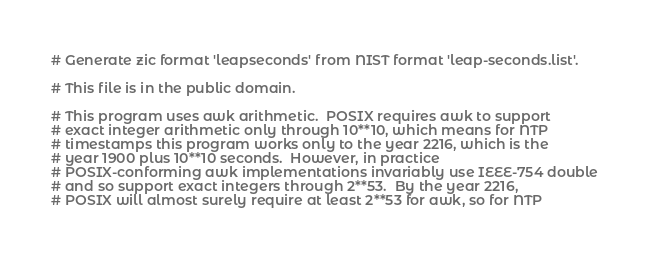Convert code to text. <code><loc_0><loc_0><loc_500><loc_500><_Awk_># Generate zic format 'leapseconds' from NIST format 'leap-seconds.list'.

# This file is in the public domain.

# This program uses awk arithmetic.  POSIX requires awk to support
# exact integer arithmetic only through 10**10, which means for NTP
# timestamps this program works only to the year 2216, which is the
# year 1900 plus 10**10 seconds.  However, in practice
# POSIX-conforming awk implementations invariably use IEEE-754 double
# and so support exact integers through 2**53.  By the year 2216,
# POSIX will almost surely require at least 2**53 for awk, so for NTP</code> 